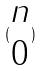Convert formula to latex. <formula><loc_0><loc_0><loc_500><loc_500>( \begin{matrix} n \\ 0 \end{matrix} )</formula> 